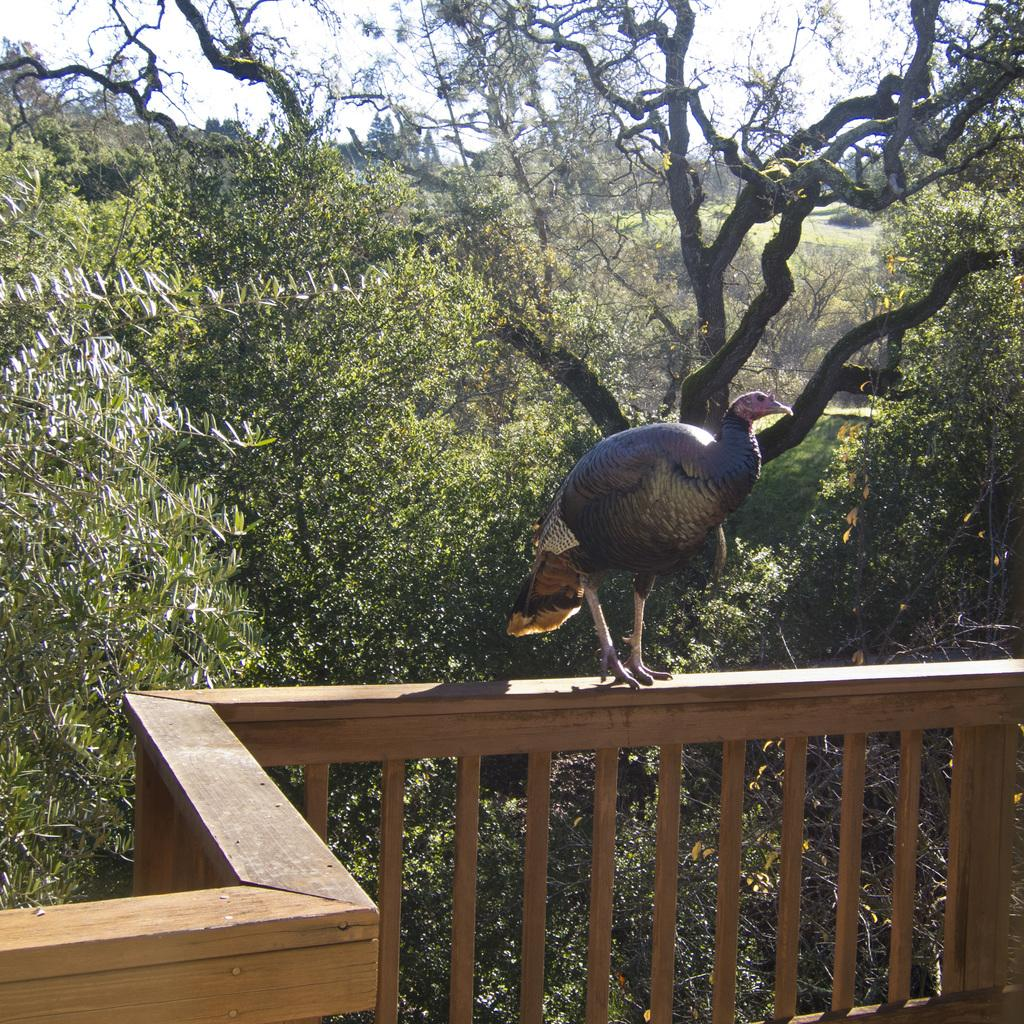What type of animal is in the image? There is a bird in the image. Where is the bird located? The bird is standing on a wooden railing. What is the color of the wooden railing? The wooden railing is brown in color. What is the color of the bird? The bird is purple in color. What can be seen in the background of the image? There are trees and the sky visible in the background of the image. What condition is the pan in when it is being transported in the image? There is no pan present in the image, and therefore no such activity can be observed. 